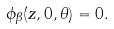<formula> <loc_0><loc_0><loc_500><loc_500>\phi _ { \beta } ( z , 0 , \theta ) = 0 .</formula> 